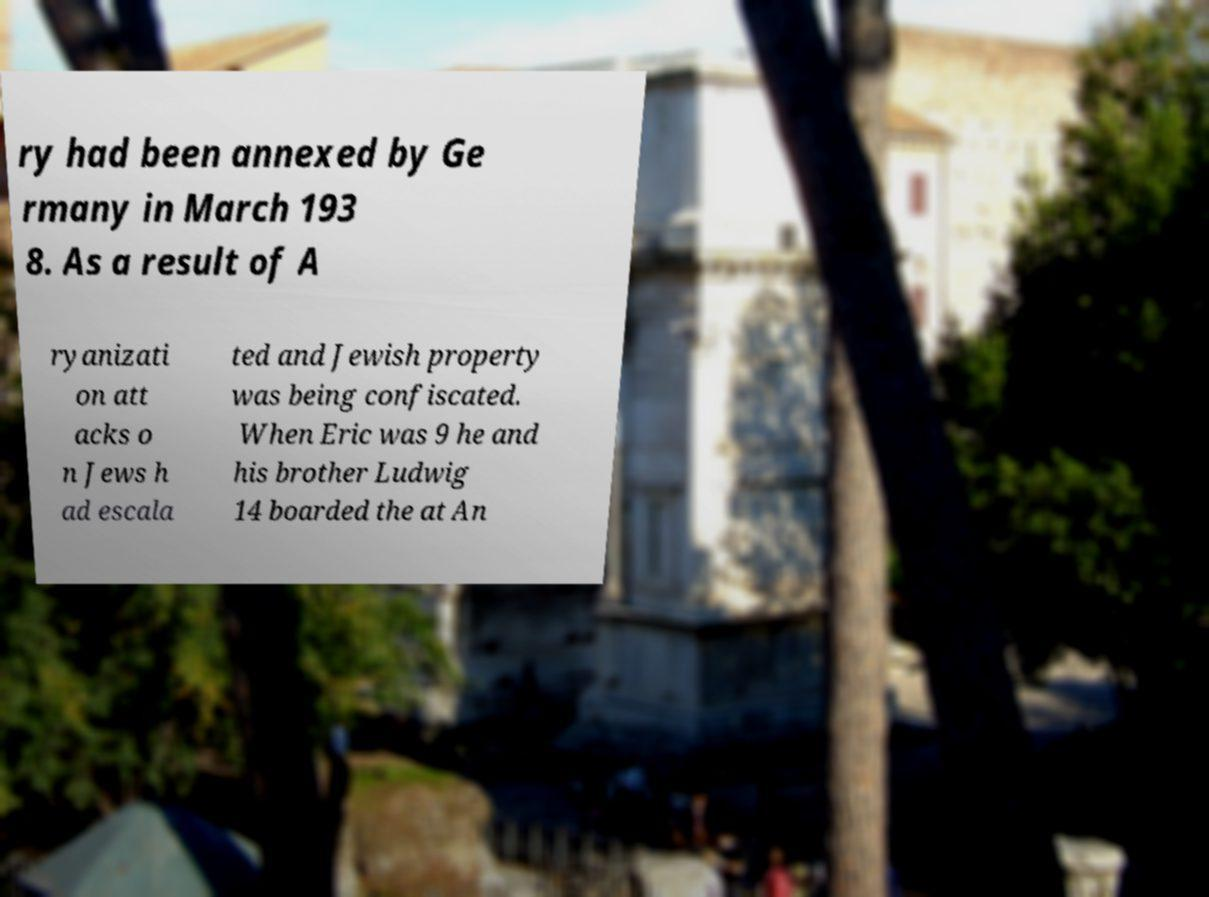There's text embedded in this image that I need extracted. Can you transcribe it verbatim? ry had been annexed by Ge rmany in March 193 8. As a result of A ryanizati on att acks o n Jews h ad escala ted and Jewish property was being confiscated. When Eric was 9 he and his brother Ludwig 14 boarded the at An 